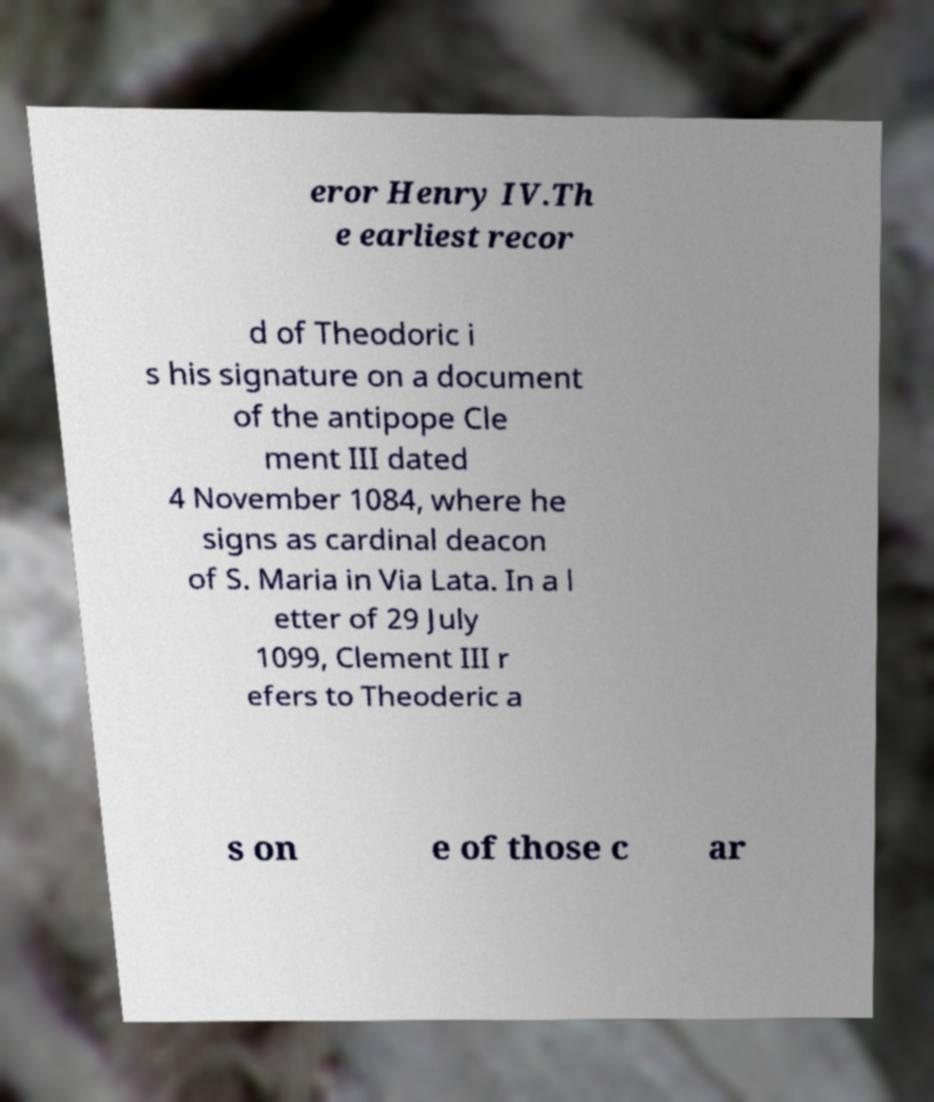Please identify and transcribe the text found in this image. eror Henry IV.Th e earliest recor d of Theodoric i s his signature on a document of the antipope Cle ment III dated 4 November 1084, where he signs as cardinal deacon of S. Maria in Via Lata. In a l etter of 29 July 1099, Clement III r efers to Theoderic a s on e of those c ar 